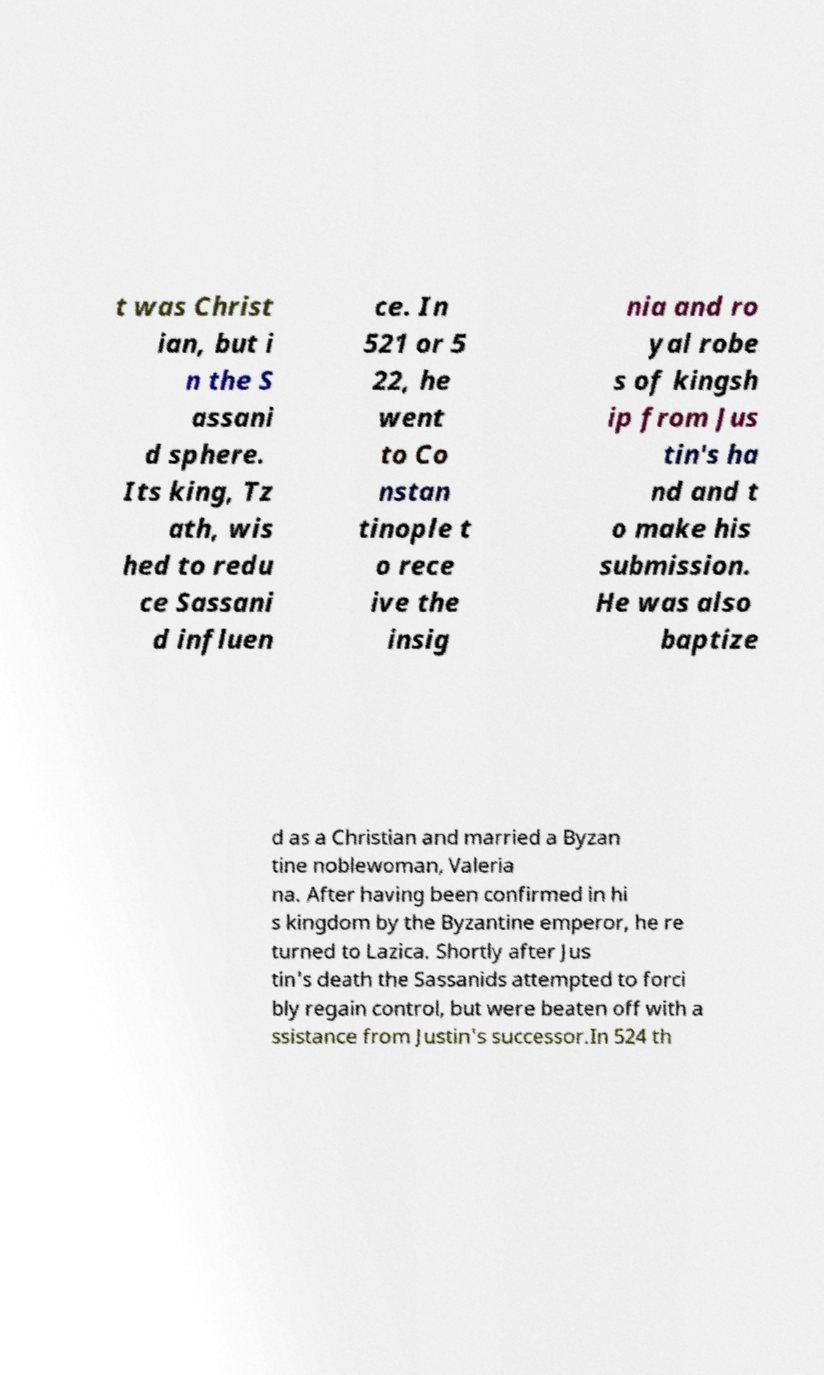Please identify and transcribe the text found in this image. t was Christ ian, but i n the S assani d sphere. Its king, Tz ath, wis hed to redu ce Sassani d influen ce. In 521 or 5 22, he went to Co nstan tinople t o rece ive the insig nia and ro yal robe s of kingsh ip from Jus tin's ha nd and t o make his submission. He was also baptize d as a Christian and married a Byzan tine noblewoman, Valeria na. After having been confirmed in hi s kingdom by the Byzantine emperor, he re turned to Lazica. Shortly after Jus tin's death the Sassanids attempted to forci bly regain control, but were beaten off with a ssistance from Justin's successor.In 524 th 